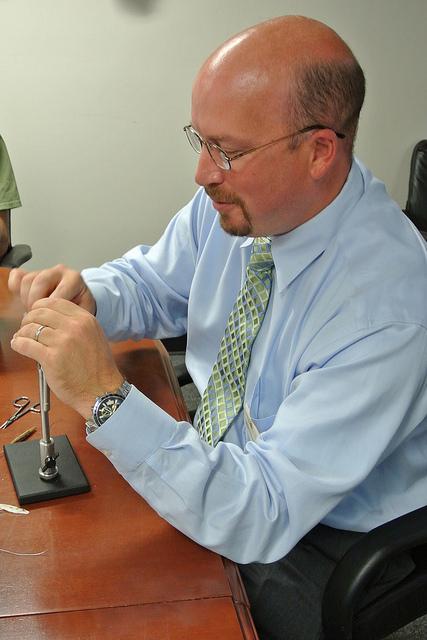How many men are there?
Answer briefly. 1. What kind of tie is this man wearing?
Be succinct. Green. What tool is on the table?
Concise answer only. Scissors. What is the sitting man doing with his hands?
Keep it brief. Holding something. Is this man bald?
Concise answer only. Yes. What color tie is he wearing?
Short answer required. Green. What is the man wearing?
Keep it brief. Shirt and tie. What is the man looking at?
Concise answer only. Metal thing. What is the gentleman doing?
Write a very short answer. Sitting. Is he wearing glasses?
Keep it brief. Yes. 